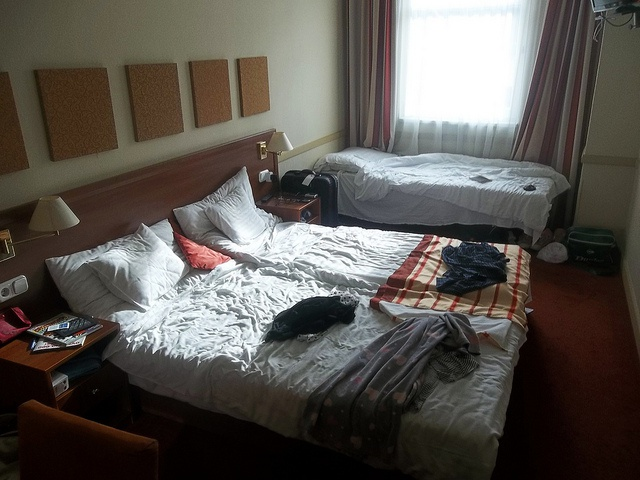Describe the objects in this image and their specific colors. I can see bed in black, gray, lightgray, and darkgray tones, bed in black, white, darkgray, and gray tones, bed in black, gray, darkgray, and lightgray tones, chair in maroon and black tones, and suitcase in black and gray tones in this image. 